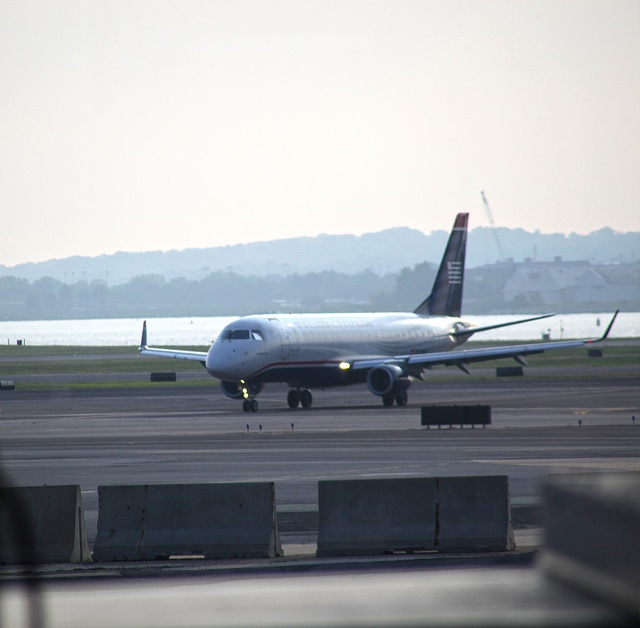Describe the objects in this image and their specific colors. I can see a airplane in lightgray, gray, black, and white tones in this image. 